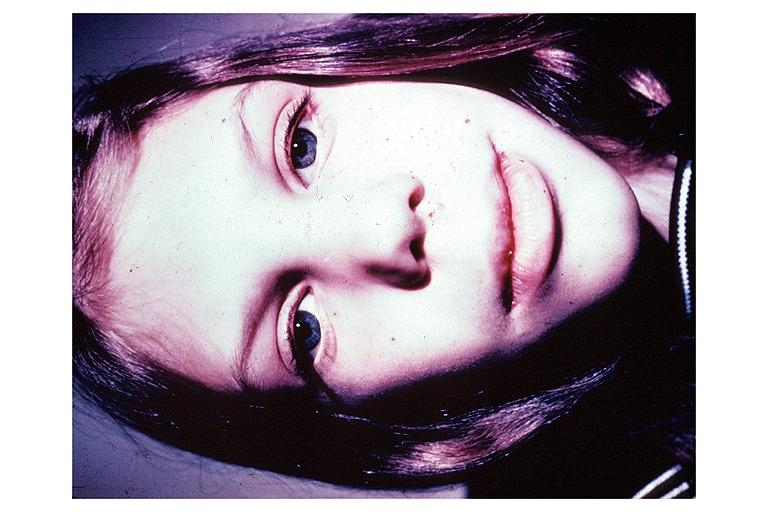does this image show multiple endocrine neoplasia type iib?
Answer the question using a single word or phrase. Yes 